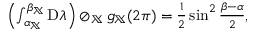<formula> <loc_0><loc_0><loc_500><loc_500>\begin{array} { r } { \left ( \int _ { \alpha _ { \mathbb { X } } } ^ { \beta _ { \mathbb { X } } } D \lambda \right ) \oslash _ { \mathbb { X } } g _ { \mathbb { X } } ( 2 \pi ) = \frac { 1 } { 2 } \sin ^ { 2 } \frac { \beta - \alpha } { 2 } , } \end{array}</formula> 